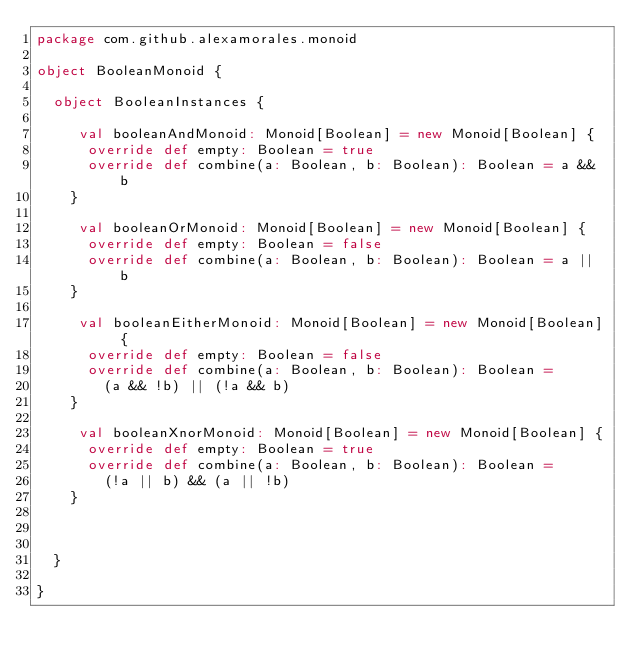Convert code to text. <code><loc_0><loc_0><loc_500><loc_500><_Scala_>package com.github.alexamorales.monoid

object BooleanMonoid {

  object BooleanInstances {

     val booleanAndMonoid: Monoid[Boolean] = new Monoid[Boolean] {
      override def empty: Boolean = true
      override def combine(a: Boolean, b: Boolean): Boolean = a && b
    }

     val booleanOrMonoid: Monoid[Boolean] = new Monoid[Boolean] {
      override def empty: Boolean = false
      override def combine(a: Boolean, b: Boolean): Boolean = a || b
    }

     val booleanEitherMonoid: Monoid[Boolean] = new Monoid[Boolean] {
      override def empty: Boolean = false
      override def combine(a: Boolean, b: Boolean): Boolean =
        (a && !b) || (!a && b)
    }

     val booleanXnorMonoid: Monoid[Boolean] = new Monoid[Boolean] {
      override def empty: Boolean = true
      override def combine(a: Boolean, b: Boolean): Boolean =
        (!a || b) && (a || !b)
    }



  }

}
</code> 